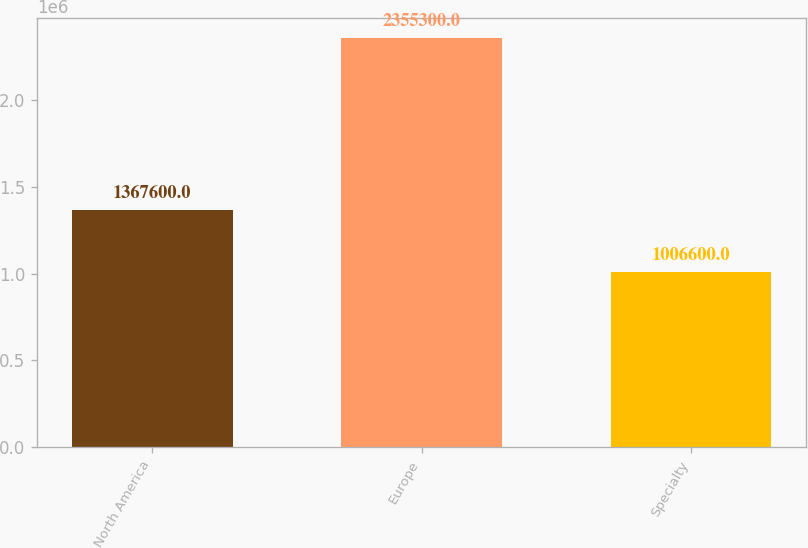Convert chart to OTSL. <chart><loc_0><loc_0><loc_500><loc_500><bar_chart><fcel>North America<fcel>Europe<fcel>Specialty<nl><fcel>1.3676e+06<fcel>2.3553e+06<fcel>1.0066e+06<nl></chart> 